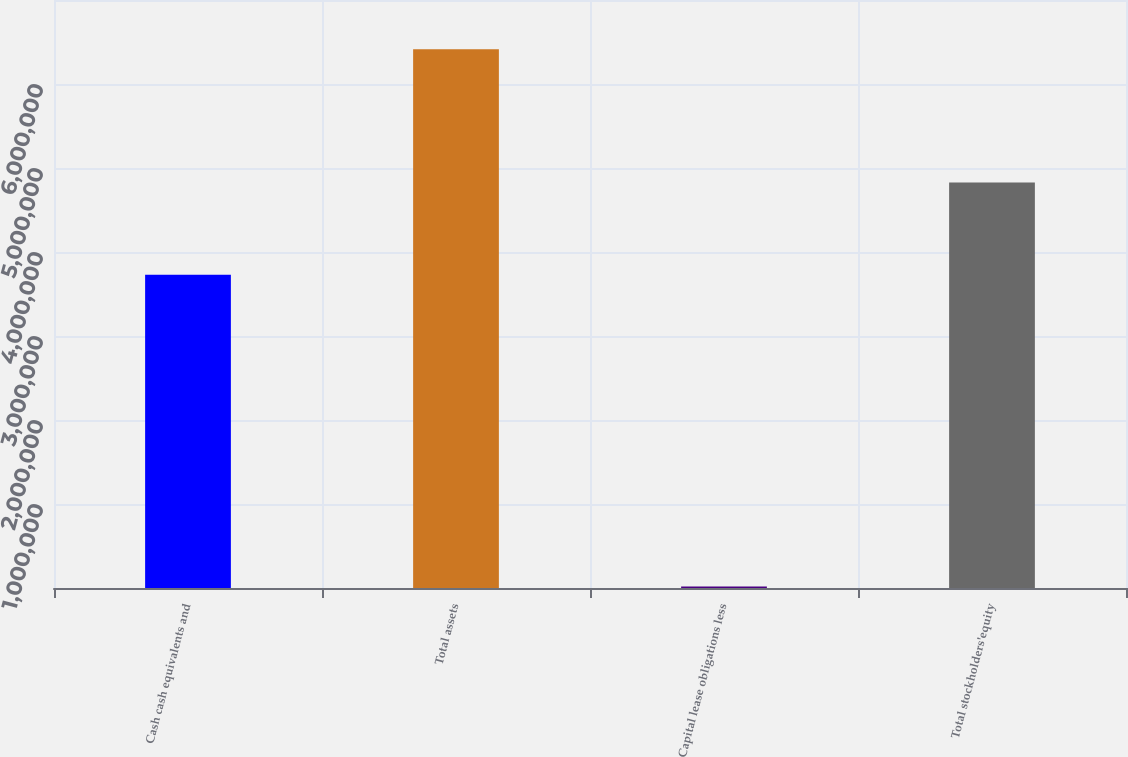Convert chart to OTSL. <chart><loc_0><loc_0><loc_500><loc_500><bar_chart><fcel>Cash cash equivalents and<fcel>Total assets<fcel>Capital lease obligations less<fcel>Total stockholders'equity<nl><fcel>3.72788e+06<fcel>6.41224e+06<fcel>18998<fcel>4.8277e+06<nl></chart> 